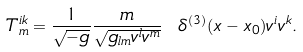<formula> <loc_0><loc_0><loc_500><loc_500>T ^ { i k } _ { m } = \frac { 1 } { \sqrt { - g } } \frac { m } { \sqrt { g _ { l m } v ^ { l } v ^ { m } } } \ \delta ^ { ( 3 ) } ( x - x _ { 0 } ) v ^ { i } v ^ { k } .</formula> 